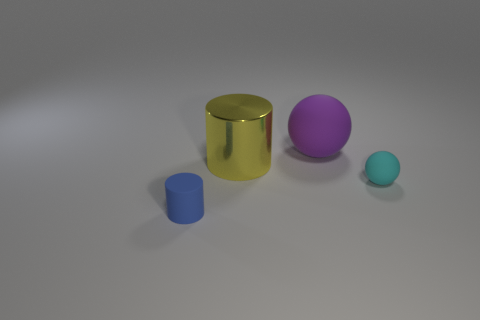Add 4 blue cylinders. How many objects exist? 8 Subtract all big metal objects. Subtract all blue rubber spheres. How many objects are left? 3 Add 4 blue cylinders. How many blue cylinders are left? 5 Add 1 cylinders. How many cylinders exist? 3 Subtract 0 blue cubes. How many objects are left? 4 